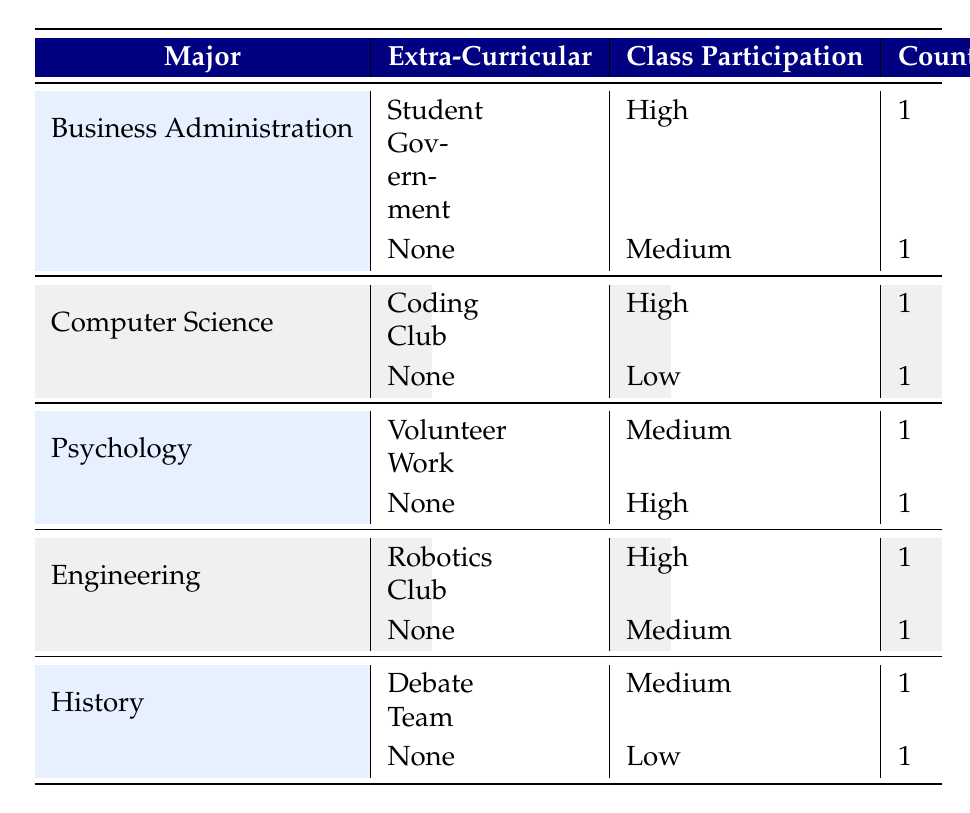What is the class participation level of Business Administration students who are involved in Student Government? The table shows that for Business Administration students, those involved in Student Government have a class participation level of High.
Answer: High How many students in total reported High class participation? In the table, High class participation is reported by Business Administration (1), Computer Science (1), Psychology (1), and Engineering (1). Adding these together gives 4 students in total.
Answer: 4 Do any Psychology students have Low class participation? The table indicates that Psychology students have Medium (1) and High (1) levels of class participation, and there are no entries showing Low class participation for them.
Answer: No What is the difference between the number of students with Medium and High class participation across all majors? The table shows that Medium class participation occurs in Business Administration (1), Psychology (1), Engineering (1), and History (1) totaling 4; High is from Business Administration (1), Computer Science (1), Psychology (1), and Engineering (1) totaling 4. Therefore, the difference is 4 - 4 = 0.
Answer: 0 Which major has students participating in extra-curricular activities that result in Medium class participation? From the table, Business Administration (None), Psychology (Volunteer Work), Engineering (None), and History (Debate Team) show Medium class participation, indicating that multiple majors fit this criterion.
Answer: Business Administration, Psychology, Engineering, History What is the class participation level of Computer Science students who are not involved in extra-curricular activities? According to the table, Computer Science students who are not involved in any extra-curricular activities report Low class participation.
Answer: Low Which major has the highest class participation among its students involved in extra-curricular activities? The highest reported class participation for extra-curricular activities is High in both Computer Science (Coding Club) and Engineering (Robotics Club), hence two majors have the same highest level.
Answer: Computer Science, Engineering Is there any student major where all participants have High class participation? In examining the table, there is no major where all students report High class participation, as majors have varying levels of class participation.
Answer: No 